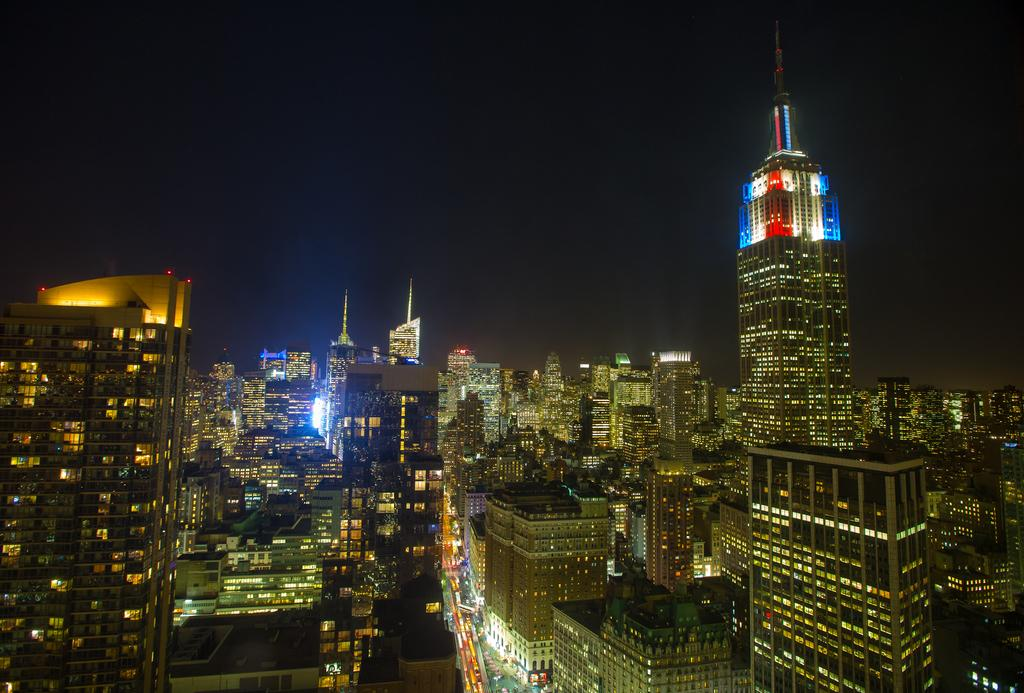What type of structures are present in the image? There are buildings in the picture. What feature do the buildings have? The buildings have glass windows. What can be seen through the windows? Lights are visible from the windows. What is the condition of the sky in the image? The sky is clear in the image. What type of apparel is being worn by the word in the image? There is no word or apparel present in the image; it features buildings with glass windows and lights visible from the windows. 